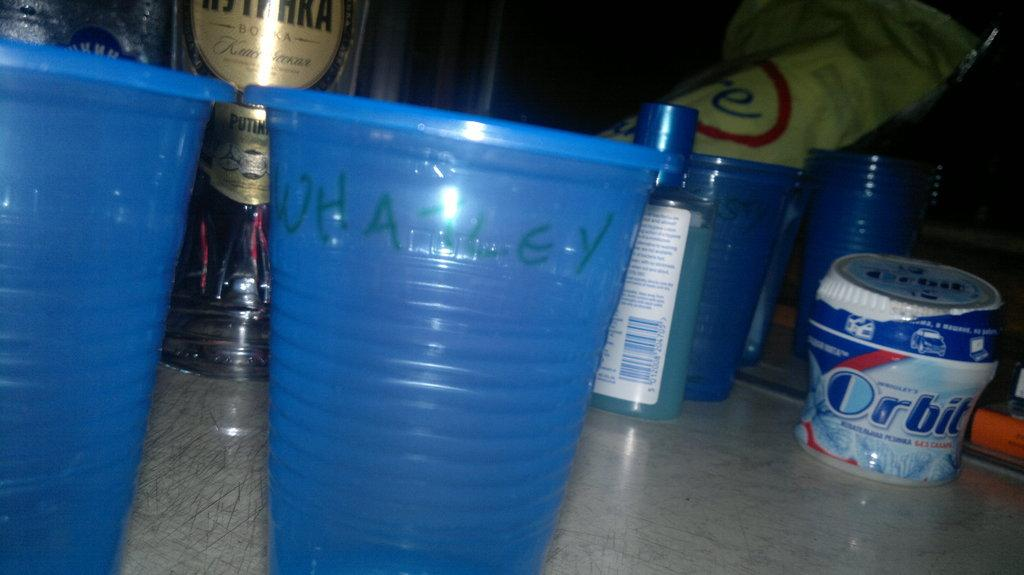<image>
Present a compact description of the photo's key features. a persons collection of bar items and cups as well as a container of Orbit gum. 